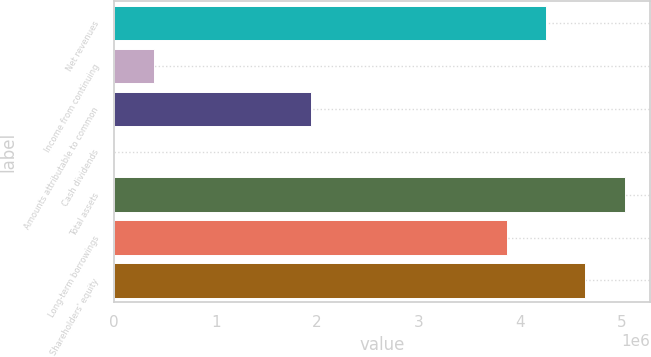Convert chart. <chart><loc_0><loc_0><loc_500><loc_500><bar_chart><fcel>Net revenues<fcel>Income from continuing<fcel>Amounts attributable to common<fcel>Cash dividends<fcel>Total assets<fcel>Long-term borrowings<fcel>Shareholders' equity<nl><fcel>4.25895e+06<fcel>387179<fcel>1.93589e+06<fcel>1.36<fcel>5.03331e+06<fcel>3.87177e+06<fcel>4.64613e+06<nl></chart> 